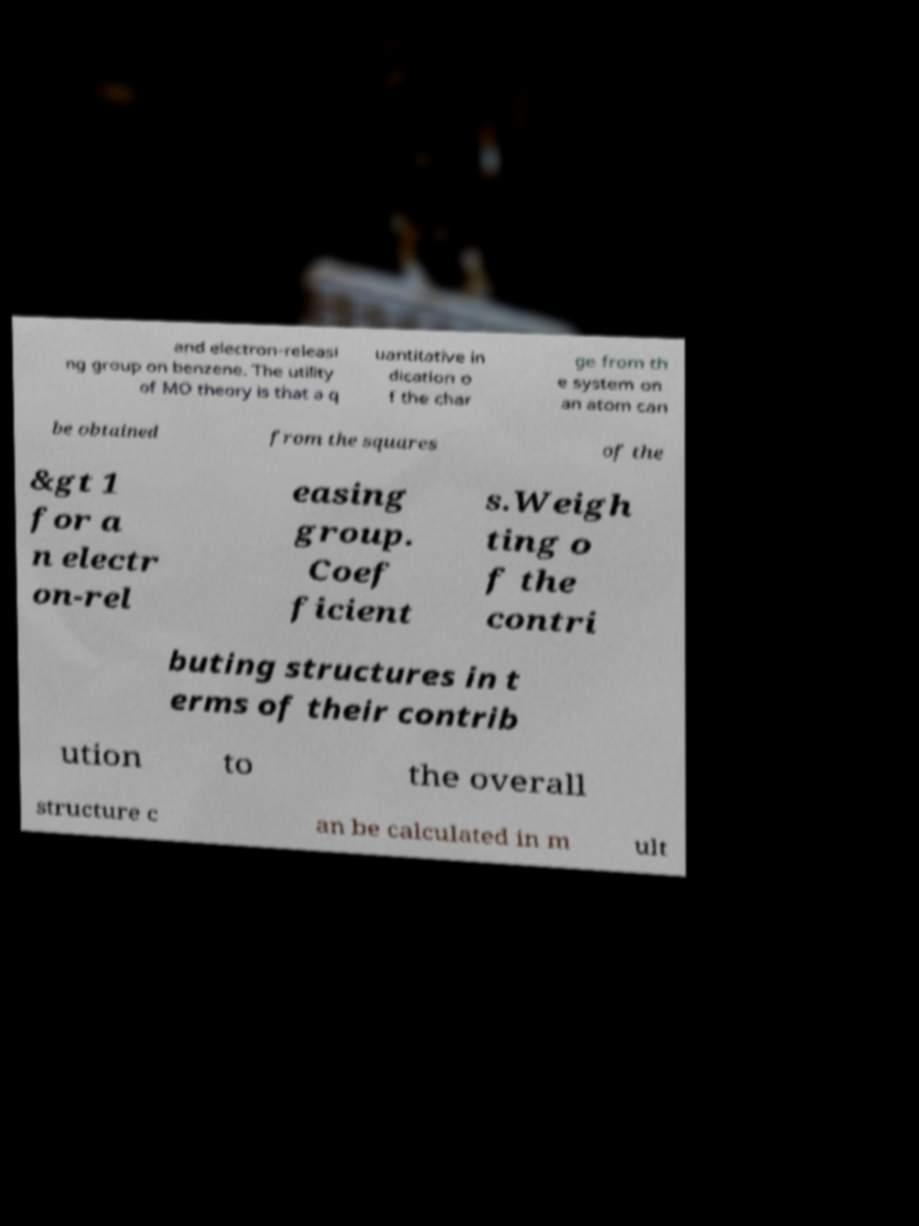Please read and relay the text visible in this image. What does it say? and electron-releasi ng group on benzene. The utility of MO theory is that a q uantitative in dication o f the char ge from th e system on an atom can be obtained from the squares of the &gt 1 for a n electr on-rel easing group. Coef ficient s.Weigh ting o f the contri buting structures in t erms of their contrib ution to the overall structure c an be calculated in m ult 